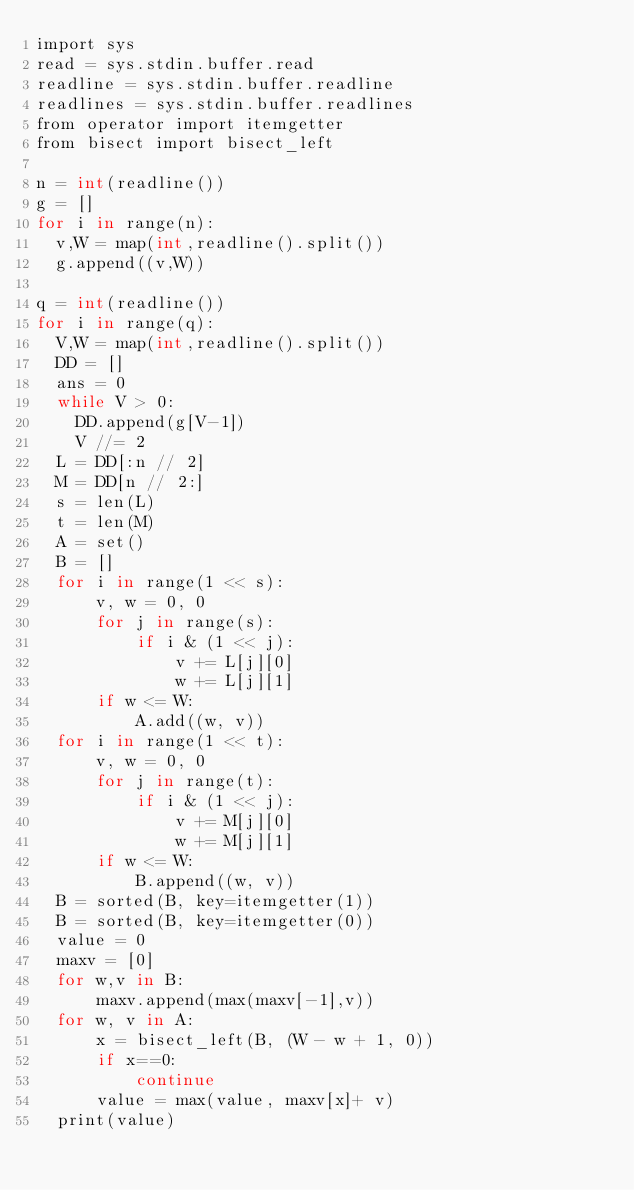Convert code to text. <code><loc_0><loc_0><loc_500><loc_500><_Cython_>import sys
read = sys.stdin.buffer.read
readline = sys.stdin.buffer.readline
readlines = sys.stdin.buffer.readlines
from operator import itemgetter
from bisect import bisect_left

n = int(readline())
g = []
for i in range(n):
  v,W = map(int,readline().split())
  g.append((v,W))
  
q = int(readline())
for i in range(q):
  V,W = map(int,readline().split())
  DD = []
  ans = 0
  while V > 0:
    DD.append(g[V-1])
    V //= 2
  L = DD[:n // 2]
  M = DD[n // 2:]
  s = len(L)
  t = len(M)
  A = set()
  B = []
  for i in range(1 << s):
      v, w = 0, 0
      for j in range(s):
          if i & (1 << j):
              v += L[j][0]
              w += L[j][1]
      if w <= W:
          A.add((w, v))
  for i in range(1 << t):
      v, w = 0, 0
      for j in range(t):
          if i & (1 << j):
              v += M[j][0]
              w += M[j][1]
      if w <= W:
          B.append((w, v))
  B = sorted(B, key=itemgetter(1))
  B = sorted(B, key=itemgetter(0))
  value = 0
  maxv = [0]
  for w,v in B:
      maxv.append(max(maxv[-1],v))
  for w, v in A:
      x = bisect_left(B, (W - w + 1, 0))
      if x==0:
          continue
      value = max(value, maxv[x]+ v)
  print(value)</code> 